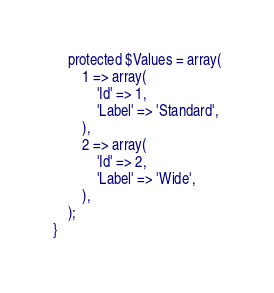<code> <loc_0><loc_0><loc_500><loc_500><_PHP_>    protected $Values = array(
        1 => array(
            'Id' => 1,
            'Label' => 'Standard',
        ),
        2 => array(
            'Id' => 2,
            'Label' => 'Wide',
        ),
    );
}
</code> 